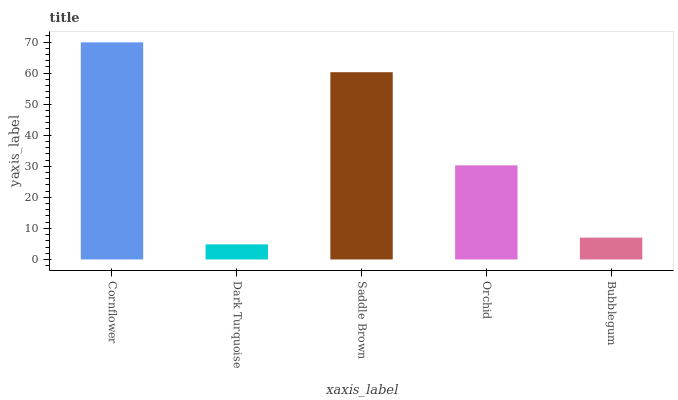Is Dark Turquoise the minimum?
Answer yes or no. Yes. Is Cornflower the maximum?
Answer yes or no. Yes. Is Saddle Brown the minimum?
Answer yes or no. No. Is Saddle Brown the maximum?
Answer yes or no. No. Is Saddle Brown greater than Dark Turquoise?
Answer yes or no. Yes. Is Dark Turquoise less than Saddle Brown?
Answer yes or no. Yes. Is Dark Turquoise greater than Saddle Brown?
Answer yes or no. No. Is Saddle Brown less than Dark Turquoise?
Answer yes or no. No. Is Orchid the high median?
Answer yes or no. Yes. Is Orchid the low median?
Answer yes or no. Yes. Is Saddle Brown the high median?
Answer yes or no. No. Is Saddle Brown the low median?
Answer yes or no. No. 